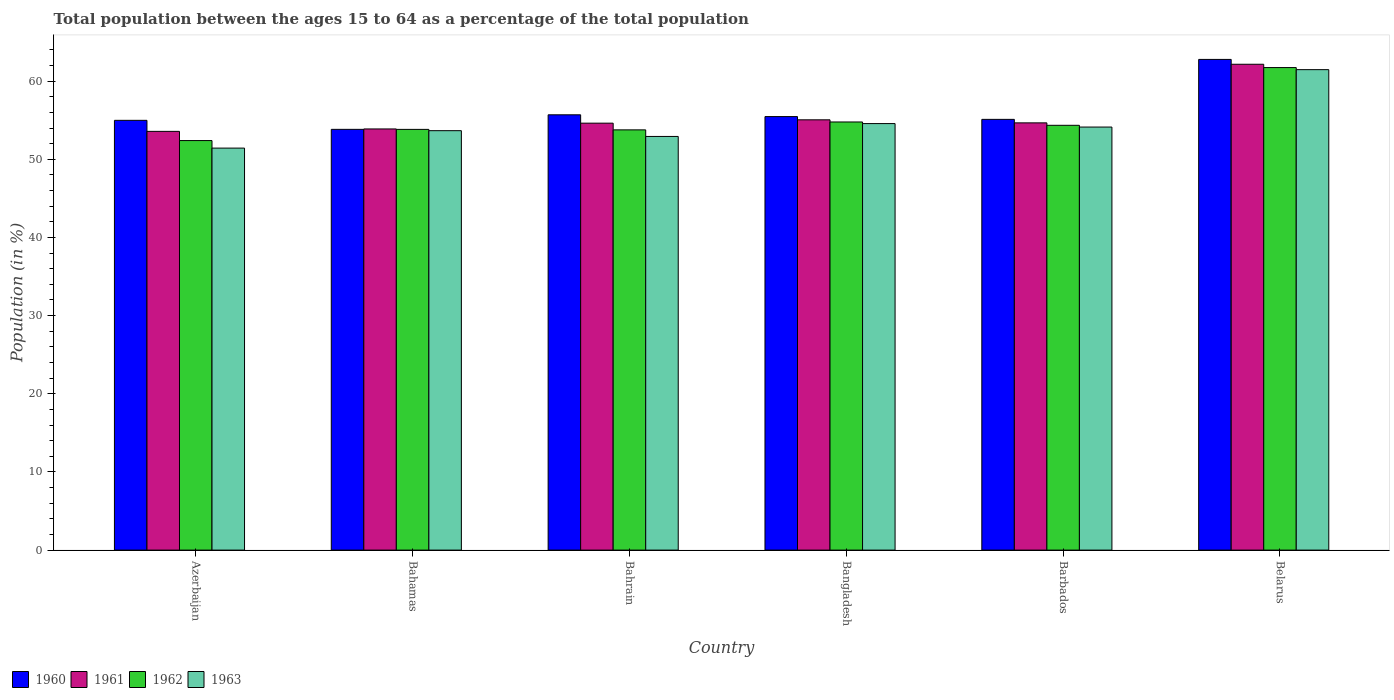How many groups of bars are there?
Ensure brevity in your answer.  6. Are the number of bars per tick equal to the number of legend labels?
Give a very brief answer. Yes. Are the number of bars on each tick of the X-axis equal?
Give a very brief answer. Yes. How many bars are there on the 1st tick from the left?
Give a very brief answer. 4. How many bars are there on the 4th tick from the right?
Keep it short and to the point. 4. What is the label of the 5th group of bars from the left?
Make the answer very short. Barbados. In how many cases, is the number of bars for a given country not equal to the number of legend labels?
Your response must be concise. 0. What is the percentage of the population ages 15 to 64 in 1960 in Barbados?
Give a very brief answer. 55.11. Across all countries, what is the maximum percentage of the population ages 15 to 64 in 1961?
Offer a very short reply. 62.16. Across all countries, what is the minimum percentage of the population ages 15 to 64 in 1961?
Make the answer very short. 53.57. In which country was the percentage of the population ages 15 to 64 in 1962 maximum?
Ensure brevity in your answer.  Belarus. In which country was the percentage of the population ages 15 to 64 in 1962 minimum?
Keep it short and to the point. Azerbaijan. What is the total percentage of the population ages 15 to 64 in 1963 in the graph?
Provide a short and direct response. 328.18. What is the difference between the percentage of the population ages 15 to 64 in 1961 in Azerbaijan and that in Bangladesh?
Ensure brevity in your answer.  -1.48. What is the difference between the percentage of the population ages 15 to 64 in 1960 in Bahrain and the percentage of the population ages 15 to 64 in 1962 in Bahamas?
Your response must be concise. 1.86. What is the average percentage of the population ages 15 to 64 in 1962 per country?
Provide a succinct answer. 55.14. What is the difference between the percentage of the population ages 15 to 64 of/in 1960 and percentage of the population ages 15 to 64 of/in 1963 in Bangladesh?
Offer a terse response. 0.89. In how many countries, is the percentage of the population ages 15 to 64 in 1962 greater than 46?
Your answer should be compact. 6. What is the ratio of the percentage of the population ages 15 to 64 in 1962 in Bahamas to that in Belarus?
Provide a succinct answer. 0.87. What is the difference between the highest and the second highest percentage of the population ages 15 to 64 in 1961?
Offer a very short reply. -7.5. What is the difference between the highest and the lowest percentage of the population ages 15 to 64 in 1961?
Offer a terse response. 8.59. Is it the case that in every country, the sum of the percentage of the population ages 15 to 64 in 1962 and percentage of the population ages 15 to 64 in 1963 is greater than the sum of percentage of the population ages 15 to 64 in 1960 and percentage of the population ages 15 to 64 in 1961?
Provide a short and direct response. No. What does the 1st bar from the right in Azerbaijan represents?
Offer a terse response. 1963. Is it the case that in every country, the sum of the percentage of the population ages 15 to 64 in 1962 and percentage of the population ages 15 to 64 in 1960 is greater than the percentage of the population ages 15 to 64 in 1963?
Your answer should be very brief. Yes. How many countries are there in the graph?
Ensure brevity in your answer.  6. What is the difference between two consecutive major ticks on the Y-axis?
Provide a short and direct response. 10. Where does the legend appear in the graph?
Provide a succinct answer. Bottom left. What is the title of the graph?
Your answer should be very brief. Total population between the ages 15 to 64 as a percentage of the total population. What is the label or title of the X-axis?
Your response must be concise. Country. What is the label or title of the Y-axis?
Give a very brief answer. Population (in %). What is the Population (in %) in 1960 in Azerbaijan?
Offer a very short reply. 54.98. What is the Population (in %) of 1961 in Azerbaijan?
Your response must be concise. 53.57. What is the Population (in %) of 1962 in Azerbaijan?
Provide a short and direct response. 52.4. What is the Population (in %) in 1963 in Azerbaijan?
Your answer should be very brief. 51.43. What is the Population (in %) of 1960 in Bahamas?
Keep it short and to the point. 53.83. What is the Population (in %) of 1961 in Bahamas?
Your answer should be very brief. 53.88. What is the Population (in %) in 1962 in Bahamas?
Keep it short and to the point. 53.83. What is the Population (in %) of 1963 in Bahamas?
Your response must be concise. 53.66. What is the Population (in %) of 1960 in Bahrain?
Keep it short and to the point. 55.69. What is the Population (in %) of 1961 in Bahrain?
Your response must be concise. 54.62. What is the Population (in %) of 1962 in Bahrain?
Ensure brevity in your answer.  53.77. What is the Population (in %) of 1963 in Bahrain?
Ensure brevity in your answer.  52.92. What is the Population (in %) of 1960 in Bangladesh?
Keep it short and to the point. 55.46. What is the Population (in %) in 1961 in Bangladesh?
Your answer should be very brief. 55.05. What is the Population (in %) of 1962 in Bangladesh?
Offer a terse response. 54.78. What is the Population (in %) in 1963 in Bangladesh?
Give a very brief answer. 54.57. What is the Population (in %) of 1960 in Barbados?
Your answer should be very brief. 55.11. What is the Population (in %) of 1961 in Barbados?
Ensure brevity in your answer.  54.66. What is the Population (in %) in 1962 in Barbados?
Your response must be concise. 54.35. What is the Population (in %) in 1963 in Barbados?
Provide a succinct answer. 54.12. What is the Population (in %) of 1960 in Belarus?
Offer a terse response. 62.78. What is the Population (in %) in 1961 in Belarus?
Your answer should be compact. 62.16. What is the Population (in %) of 1962 in Belarus?
Offer a terse response. 61.74. What is the Population (in %) in 1963 in Belarus?
Offer a terse response. 61.47. Across all countries, what is the maximum Population (in %) of 1960?
Offer a very short reply. 62.78. Across all countries, what is the maximum Population (in %) in 1961?
Give a very brief answer. 62.16. Across all countries, what is the maximum Population (in %) of 1962?
Make the answer very short. 61.74. Across all countries, what is the maximum Population (in %) of 1963?
Keep it short and to the point. 61.47. Across all countries, what is the minimum Population (in %) of 1960?
Make the answer very short. 53.83. Across all countries, what is the minimum Population (in %) in 1961?
Your answer should be compact. 53.57. Across all countries, what is the minimum Population (in %) in 1962?
Offer a very short reply. 52.4. Across all countries, what is the minimum Population (in %) of 1963?
Ensure brevity in your answer.  51.43. What is the total Population (in %) in 1960 in the graph?
Give a very brief answer. 337.86. What is the total Population (in %) of 1961 in the graph?
Give a very brief answer. 333.95. What is the total Population (in %) in 1962 in the graph?
Make the answer very short. 330.85. What is the total Population (in %) of 1963 in the graph?
Your response must be concise. 328.18. What is the difference between the Population (in %) of 1960 in Azerbaijan and that in Bahamas?
Provide a short and direct response. 1.15. What is the difference between the Population (in %) in 1961 in Azerbaijan and that in Bahamas?
Ensure brevity in your answer.  -0.31. What is the difference between the Population (in %) in 1962 in Azerbaijan and that in Bahamas?
Provide a succinct answer. -1.43. What is the difference between the Population (in %) of 1963 in Azerbaijan and that in Bahamas?
Your answer should be compact. -2.23. What is the difference between the Population (in %) of 1960 in Azerbaijan and that in Bahrain?
Provide a succinct answer. -0.71. What is the difference between the Population (in %) of 1961 in Azerbaijan and that in Bahrain?
Your answer should be very brief. -1.05. What is the difference between the Population (in %) in 1962 in Azerbaijan and that in Bahrain?
Your answer should be very brief. -1.37. What is the difference between the Population (in %) of 1963 in Azerbaijan and that in Bahrain?
Give a very brief answer. -1.49. What is the difference between the Population (in %) in 1960 in Azerbaijan and that in Bangladesh?
Your answer should be very brief. -0.48. What is the difference between the Population (in %) of 1961 in Azerbaijan and that in Bangladesh?
Your answer should be compact. -1.48. What is the difference between the Population (in %) in 1962 in Azerbaijan and that in Bangladesh?
Make the answer very short. -2.38. What is the difference between the Population (in %) of 1963 in Azerbaijan and that in Bangladesh?
Provide a succinct answer. -3.14. What is the difference between the Population (in %) in 1960 in Azerbaijan and that in Barbados?
Provide a succinct answer. -0.12. What is the difference between the Population (in %) in 1961 in Azerbaijan and that in Barbados?
Make the answer very short. -1.09. What is the difference between the Population (in %) of 1962 in Azerbaijan and that in Barbados?
Keep it short and to the point. -1.95. What is the difference between the Population (in %) in 1963 in Azerbaijan and that in Barbados?
Keep it short and to the point. -2.69. What is the difference between the Population (in %) of 1960 in Azerbaijan and that in Belarus?
Provide a succinct answer. -7.79. What is the difference between the Population (in %) in 1961 in Azerbaijan and that in Belarus?
Make the answer very short. -8.59. What is the difference between the Population (in %) in 1962 in Azerbaijan and that in Belarus?
Provide a succinct answer. -9.34. What is the difference between the Population (in %) of 1963 in Azerbaijan and that in Belarus?
Offer a very short reply. -10.04. What is the difference between the Population (in %) in 1960 in Bahamas and that in Bahrain?
Your response must be concise. -1.86. What is the difference between the Population (in %) in 1961 in Bahamas and that in Bahrain?
Make the answer very short. -0.74. What is the difference between the Population (in %) of 1962 in Bahamas and that in Bahrain?
Offer a terse response. 0.06. What is the difference between the Population (in %) in 1963 in Bahamas and that in Bahrain?
Make the answer very short. 0.74. What is the difference between the Population (in %) in 1960 in Bahamas and that in Bangladesh?
Make the answer very short. -1.63. What is the difference between the Population (in %) of 1961 in Bahamas and that in Bangladesh?
Provide a succinct answer. -1.17. What is the difference between the Population (in %) in 1962 in Bahamas and that in Bangladesh?
Provide a succinct answer. -0.95. What is the difference between the Population (in %) of 1963 in Bahamas and that in Bangladesh?
Your response must be concise. -0.91. What is the difference between the Population (in %) of 1960 in Bahamas and that in Barbados?
Ensure brevity in your answer.  -1.28. What is the difference between the Population (in %) in 1961 in Bahamas and that in Barbados?
Offer a very short reply. -0.78. What is the difference between the Population (in %) in 1962 in Bahamas and that in Barbados?
Offer a very short reply. -0.52. What is the difference between the Population (in %) of 1963 in Bahamas and that in Barbados?
Make the answer very short. -0.46. What is the difference between the Population (in %) of 1960 in Bahamas and that in Belarus?
Your answer should be very brief. -8.95. What is the difference between the Population (in %) of 1961 in Bahamas and that in Belarus?
Provide a succinct answer. -8.28. What is the difference between the Population (in %) of 1962 in Bahamas and that in Belarus?
Ensure brevity in your answer.  -7.91. What is the difference between the Population (in %) of 1963 in Bahamas and that in Belarus?
Your response must be concise. -7.81. What is the difference between the Population (in %) of 1960 in Bahrain and that in Bangladesh?
Give a very brief answer. 0.23. What is the difference between the Population (in %) in 1961 in Bahrain and that in Bangladesh?
Your answer should be very brief. -0.43. What is the difference between the Population (in %) in 1962 in Bahrain and that in Bangladesh?
Keep it short and to the point. -1.01. What is the difference between the Population (in %) of 1963 in Bahrain and that in Bangladesh?
Keep it short and to the point. -1.65. What is the difference between the Population (in %) in 1960 in Bahrain and that in Barbados?
Your answer should be very brief. 0.58. What is the difference between the Population (in %) of 1961 in Bahrain and that in Barbados?
Offer a very short reply. -0.04. What is the difference between the Population (in %) of 1962 in Bahrain and that in Barbados?
Offer a terse response. -0.58. What is the difference between the Population (in %) of 1963 in Bahrain and that in Barbados?
Provide a succinct answer. -1.2. What is the difference between the Population (in %) in 1960 in Bahrain and that in Belarus?
Keep it short and to the point. -7.09. What is the difference between the Population (in %) of 1961 in Bahrain and that in Belarus?
Your answer should be very brief. -7.54. What is the difference between the Population (in %) of 1962 in Bahrain and that in Belarus?
Give a very brief answer. -7.97. What is the difference between the Population (in %) of 1963 in Bahrain and that in Belarus?
Offer a terse response. -8.55. What is the difference between the Population (in %) in 1960 in Bangladesh and that in Barbados?
Provide a short and direct response. 0.36. What is the difference between the Population (in %) in 1961 in Bangladesh and that in Barbados?
Provide a short and direct response. 0.39. What is the difference between the Population (in %) of 1962 in Bangladesh and that in Barbados?
Ensure brevity in your answer.  0.43. What is the difference between the Population (in %) of 1963 in Bangladesh and that in Barbados?
Offer a terse response. 0.45. What is the difference between the Population (in %) of 1960 in Bangladesh and that in Belarus?
Ensure brevity in your answer.  -7.32. What is the difference between the Population (in %) in 1961 in Bangladesh and that in Belarus?
Provide a succinct answer. -7.11. What is the difference between the Population (in %) of 1962 in Bangladesh and that in Belarus?
Your answer should be compact. -6.96. What is the difference between the Population (in %) of 1963 in Bangladesh and that in Belarus?
Give a very brief answer. -6.9. What is the difference between the Population (in %) of 1960 in Barbados and that in Belarus?
Offer a very short reply. -7.67. What is the difference between the Population (in %) in 1961 in Barbados and that in Belarus?
Your response must be concise. -7.5. What is the difference between the Population (in %) of 1962 in Barbados and that in Belarus?
Provide a short and direct response. -7.39. What is the difference between the Population (in %) of 1963 in Barbados and that in Belarus?
Provide a succinct answer. -7.34. What is the difference between the Population (in %) in 1960 in Azerbaijan and the Population (in %) in 1961 in Bahamas?
Give a very brief answer. 1.1. What is the difference between the Population (in %) of 1960 in Azerbaijan and the Population (in %) of 1962 in Bahamas?
Give a very brief answer. 1.16. What is the difference between the Population (in %) in 1960 in Azerbaijan and the Population (in %) in 1963 in Bahamas?
Your answer should be very brief. 1.32. What is the difference between the Population (in %) in 1961 in Azerbaijan and the Population (in %) in 1962 in Bahamas?
Provide a short and direct response. -0.25. What is the difference between the Population (in %) in 1961 in Azerbaijan and the Population (in %) in 1963 in Bahamas?
Keep it short and to the point. -0.09. What is the difference between the Population (in %) of 1962 in Azerbaijan and the Population (in %) of 1963 in Bahamas?
Ensure brevity in your answer.  -1.27. What is the difference between the Population (in %) of 1960 in Azerbaijan and the Population (in %) of 1961 in Bahrain?
Give a very brief answer. 0.36. What is the difference between the Population (in %) in 1960 in Azerbaijan and the Population (in %) in 1962 in Bahrain?
Give a very brief answer. 1.22. What is the difference between the Population (in %) in 1960 in Azerbaijan and the Population (in %) in 1963 in Bahrain?
Your answer should be very brief. 2.06. What is the difference between the Population (in %) in 1961 in Azerbaijan and the Population (in %) in 1962 in Bahrain?
Make the answer very short. -0.19. What is the difference between the Population (in %) in 1961 in Azerbaijan and the Population (in %) in 1963 in Bahrain?
Offer a very short reply. 0.65. What is the difference between the Population (in %) in 1962 in Azerbaijan and the Population (in %) in 1963 in Bahrain?
Your answer should be very brief. -0.53. What is the difference between the Population (in %) of 1960 in Azerbaijan and the Population (in %) of 1961 in Bangladesh?
Offer a terse response. -0.07. What is the difference between the Population (in %) of 1960 in Azerbaijan and the Population (in %) of 1962 in Bangladesh?
Keep it short and to the point. 0.21. What is the difference between the Population (in %) of 1960 in Azerbaijan and the Population (in %) of 1963 in Bangladesh?
Keep it short and to the point. 0.41. What is the difference between the Population (in %) in 1961 in Azerbaijan and the Population (in %) in 1962 in Bangladesh?
Make the answer very short. -1.2. What is the difference between the Population (in %) of 1961 in Azerbaijan and the Population (in %) of 1963 in Bangladesh?
Keep it short and to the point. -1. What is the difference between the Population (in %) in 1962 in Azerbaijan and the Population (in %) in 1963 in Bangladesh?
Your response must be concise. -2.17. What is the difference between the Population (in %) of 1960 in Azerbaijan and the Population (in %) of 1961 in Barbados?
Your response must be concise. 0.32. What is the difference between the Population (in %) of 1960 in Azerbaijan and the Population (in %) of 1962 in Barbados?
Provide a short and direct response. 0.64. What is the difference between the Population (in %) in 1960 in Azerbaijan and the Population (in %) in 1963 in Barbados?
Give a very brief answer. 0.86. What is the difference between the Population (in %) in 1961 in Azerbaijan and the Population (in %) in 1962 in Barbados?
Provide a succinct answer. -0.78. What is the difference between the Population (in %) of 1961 in Azerbaijan and the Population (in %) of 1963 in Barbados?
Offer a very short reply. -0.55. What is the difference between the Population (in %) in 1962 in Azerbaijan and the Population (in %) in 1963 in Barbados?
Offer a terse response. -1.73. What is the difference between the Population (in %) of 1960 in Azerbaijan and the Population (in %) of 1961 in Belarus?
Offer a terse response. -7.17. What is the difference between the Population (in %) of 1960 in Azerbaijan and the Population (in %) of 1962 in Belarus?
Provide a short and direct response. -6.75. What is the difference between the Population (in %) in 1960 in Azerbaijan and the Population (in %) in 1963 in Belarus?
Offer a terse response. -6.48. What is the difference between the Population (in %) of 1961 in Azerbaijan and the Population (in %) of 1962 in Belarus?
Ensure brevity in your answer.  -8.16. What is the difference between the Population (in %) of 1961 in Azerbaijan and the Population (in %) of 1963 in Belarus?
Give a very brief answer. -7.9. What is the difference between the Population (in %) in 1962 in Azerbaijan and the Population (in %) in 1963 in Belarus?
Give a very brief answer. -9.07. What is the difference between the Population (in %) in 1960 in Bahamas and the Population (in %) in 1961 in Bahrain?
Your answer should be very brief. -0.79. What is the difference between the Population (in %) in 1960 in Bahamas and the Population (in %) in 1962 in Bahrain?
Offer a very short reply. 0.07. What is the difference between the Population (in %) of 1960 in Bahamas and the Population (in %) of 1963 in Bahrain?
Your answer should be very brief. 0.91. What is the difference between the Population (in %) in 1961 in Bahamas and the Population (in %) in 1962 in Bahrain?
Your answer should be compact. 0.12. What is the difference between the Population (in %) in 1961 in Bahamas and the Population (in %) in 1963 in Bahrain?
Your answer should be very brief. 0.96. What is the difference between the Population (in %) in 1962 in Bahamas and the Population (in %) in 1963 in Bahrain?
Your response must be concise. 0.9. What is the difference between the Population (in %) in 1960 in Bahamas and the Population (in %) in 1961 in Bangladesh?
Your answer should be compact. -1.22. What is the difference between the Population (in %) in 1960 in Bahamas and the Population (in %) in 1962 in Bangladesh?
Offer a very short reply. -0.94. What is the difference between the Population (in %) of 1960 in Bahamas and the Population (in %) of 1963 in Bangladesh?
Your response must be concise. -0.74. What is the difference between the Population (in %) in 1961 in Bahamas and the Population (in %) in 1962 in Bangladesh?
Provide a short and direct response. -0.89. What is the difference between the Population (in %) in 1961 in Bahamas and the Population (in %) in 1963 in Bangladesh?
Offer a terse response. -0.69. What is the difference between the Population (in %) of 1962 in Bahamas and the Population (in %) of 1963 in Bangladesh?
Your answer should be compact. -0.74. What is the difference between the Population (in %) of 1960 in Bahamas and the Population (in %) of 1961 in Barbados?
Provide a short and direct response. -0.83. What is the difference between the Population (in %) of 1960 in Bahamas and the Population (in %) of 1962 in Barbados?
Offer a terse response. -0.52. What is the difference between the Population (in %) in 1960 in Bahamas and the Population (in %) in 1963 in Barbados?
Ensure brevity in your answer.  -0.29. What is the difference between the Population (in %) of 1961 in Bahamas and the Population (in %) of 1962 in Barbados?
Your answer should be compact. -0.46. What is the difference between the Population (in %) of 1961 in Bahamas and the Population (in %) of 1963 in Barbados?
Give a very brief answer. -0.24. What is the difference between the Population (in %) of 1962 in Bahamas and the Population (in %) of 1963 in Barbados?
Offer a very short reply. -0.3. What is the difference between the Population (in %) in 1960 in Bahamas and the Population (in %) in 1961 in Belarus?
Make the answer very short. -8.33. What is the difference between the Population (in %) in 1960 in Bahamas and the Population (in %) in 1962 in Belarus?
Your response must be concise. -7.91. What is the difference between the Population (in %) in 1960 in Bahamas and the Population (in %) in 1963 in Belarus?
Your answer should be compact. -7.64. What is the difference between the Population (in %) in 1961 in Bahamas and the Population (in %) in 1962 in Belarus?
Provide a short and direct response. -7.85. What is the difference between the Population (in %) in 1961 in Bahamas and the Population (in %) in 1963 in Belarus?
Make the answer very short. -7.59. What is the difference between the Population (in %) of 1962 in Bahamas and the Population (in %) of 1963 in Belarus?
Your response must be concise. -7.64. What is the difference between the Population (in %) in 1960 in Bahrain and the Population (in %) in 1961 in Bangladesh?
Provide a succinct answer. 0.64. What is the difference between the Population (in %) in 1960 in Bahrain and the Population (in %) in 1962 in Bangladesh?
Provide a succinct answer. 0.92. What is the difference between the Population (in %) of 1960 in Bahrain and the Population (in %) of 1963 in Bangladesh?
Ensure brevity in your answer.  1.12. What is the difference between the Population (in %) of 1961 in Bahrain and the Population (in %) of 1962 in Bangladesh?
Make the answer very short. -0.15. What is the difference between the Population (in %) of 1961 in Bahrain and the Population (in %) of 1963 in Bangladesh?
Your response must be concise. 0.05. What is the difference between the Population (in %) of 1962 in Bahrain and the Population (in %) of 1963 in Bangladesh?
Provide a succinct answer. -0.8. What is the difference between the Population (in %) in 1960 in Bahrain and the Population (in %) in 1961 in Barbados?
Make the answer very short. 1.03. What is the difference between the Population (in %) in 1960 in Bahrain and the Population (in %) in 1962 in Barbados?
Your answer should be very brief. 1.34. What is the difference between the Population (in %) of 1960 in Bahrain and the Population (in %) of 1963 in Barbados?
Keep it short and to the point. 1.57. What is the difference between the Population (in %) in 1961 in Bahrain and the Population (in %) in 1962 in Barbados?
Give a very brief answer. 0.27. What is the difference between the Population (in %) of 1961 in Bahrain and the Population (in %) of 1963 in Barbados?
Offer a terse response. 0.5. What is the difference between the Population (in %) of 1962 in Bahrain and the Population (in %) of 1963 in Barbados?
Give a very brief answer. -0.36. What is the difference between the Population (in %) in 1960 in Bahrain and the Population (in %) in 1961 in Belarus?
Provide a short and direct response. -6.47. What is the difference between the Population (in %) of 1960 in Bahrain and the Population (in %) of 1962 in Belarus?
Make the answer very short. -6.04. What is the difference between the Population (in %) of 1960 in Bahrain and the Population (in %) of 1963 in Belarus?
Keep it short and to the point. -5.78. What is the difference between the Population (in %) of 1961 in Bahrain and the Population (in %) of 1962 in Belarus?
Provide a succinct answer. -7.11. What is the difference between the Population (in %) in 1961 in Bahrain and the Population (in %) in 1963 in Belarus?
Ensure brevity in your answer.  -6.85. What is the difference between the Population (in %) in 1962 in Bahrain and the Population (in %) in 1963 in Belarus?
Keep it short and to the point. -7.7. What is the difference between the Population (in %) of 1960 in Bangladesh and the Population (in %) of 1961 in Barbados?
Provide a succinct answer. 0.8. What is the difference between the Population (in %) in 1960 in Bangladesh and the Population (in %) in 1962 in Barbados?
Ensure brevity in your answer.  1.12. What is the difference between the Population (in %) of 1960 in Bangladesh and the Population (in %) of 1963 in Barbados?
Offer a terse response. 1.34. What is the difference between the Population (in %) in 1961 in Bangladesh and the Population (in %) in 1962 in Barbados?
Provide a succinct answer. 0.7. What is the difference between the Population (in %) of 1961 in Bangladesh and the Population (in %) of 1963 in Barbados?
Provide a succinct answer. 0.93. What is the difference between the Population (in %) in 1962 in Bangladesh and the Population (in %) in 1963 in Barbados?
Offer a very short reply. 0.65. What is the difference between the Population (in %) in 1960 in Bangladesh and the Population (in %) in 1961 in Belarus?
Offer a very short reply. -6.69. What is the difference between the Population (in %) in 1960 in Bangladesh and the Population (in %) in 1962 in Belarus?
Make the answer very short. -6.27. What is the difference between the Population (in %) of 1960 in Bangladesh and the Population (in %) of 1963 in Belarus?
Provide a succinct answer. -6. What is the difference between the Population (in %) of 1961 in Bangladesh and the Population (in %) of 1962 in Belarus?
Provide a short and direct response. -6.69. What is the difference between the Population (in %) of 1961 in Bangladesh and the Population (in %) of 1963 in Belarus?
Provide a short and direct response. -6.42. What is the difference between the Population (in %) of 1962 in Bangladesh and the Population (in %) of 1963 in Belarus?
Make the answer very short. -6.69. What is the difference between the Population (in %) in 1960 in Barbados and the Population (in %) in 1961 in Belarus?
Your answer should be compact. -7.05. What is the difference between the Population (in %) of 1960 in Barbados and the Population (in %) of 1962 in Belarus?
Your response must be concise. -6.63. What is the difference between the Population (in %) of 1960 in Barbados and the Population (in %) of 1963 in Belarus?
Provide a short and direct response. -6.36. What is the difference between the Population (in %) of 1961 in Barbados and the Population (in %) of 1962 in Belarus?
Provide a succinct answer. -7.07. What is the difference between the Population (in %) in 1961 in Barbados and the Population (in %) in 1963 in Belarus?
Give a very brief answer. -6.81. What is the difference between the Population (in %) of 1962 in Barbados and the Population (in %) of 1963 in Belarus?
Provide a succinct answer. -7.12. What is the average Population (in %) in 1960 per country?
Your answer should be compact. 56.31. What is the average Population (in %) in 1961 per country?
Your answer should be very brief. 55.66. What is the average Population (in %) in 1962 per country?
Give a very brief answer. 55.14. What is the average Population (in %) in 1963 per country?
Offer a terse response. 54.7. What is the difference between the Population (in %) in 1960 and Population (in %) in 1961 in Azerbaijan?
Your answer should be compact. 1.41. What is the difference between the Population (in %) in 1960 and Population (in %) in 1962 in Azerbaijan?
Give a very brief answer. 2.59. What is the difference between the Population (in %) in 1960 and Population (in %) in 1963 in Azerbaijan?
Provide a short and direct response. 3.55. What is the difference between the Population (in %) of 1961 and Population (in %) of 1962 in Azerbaijan?
Your answer should be very brief. 1.18. What is the difference between the Population (in %) in 1961 and Population (in %) in 1963 in Azerbaijan?
Provide a short and direct response. 2.14. What is the difference between the Population (in %) in 1962 and Population (in %) in 1963 in Azerbaijan?
Provide a succinct answer. 0.96. What is the difference between the Population (in %) in 1960 and Population (in %) in 1961 in Bahamas?
Make the answer very short. -0.05. What is the difference between the Population (in %) of 1960 and Population (in %) of 1962 in Bahamas?
Offer a terse response. 0. What is the difference between the Population (in %) of 1960 and Population (in %) of 1963 in Bahamas?
Provide a succinct answer. 0.17. What is the difference between the Population (in %) of 1961 and Population (in %) of 1962 in Bahamas?
Give a very brief answer. 0.06. What is the difference between the Population (in %) in 1961 and Population (in %) in 1963 in Bahamas?
Offer a very short reply. 0.22. What is the difference between the Population (in %) of 1962 and Population (in %) of 1963 in Bahamas?
Make the answer very short. 0.17. What is the difference between the Population (in %) in 1960 and Population (in %) in 1961 in Bahrain?
Make the answer very short. 1.07. What is the difference between the Population (in %) in 1960 and Population (in %) in 1962 in Bahrain?
Provide a short and direct response. 1.93. What is the difference between the Population (in %) of 1960 and Population (in %) of 1963 in Bahrain?
Keep it short and to the point. 2.77. What is the difference between the Population (in %) of 1961 and Population (in %) of 1962 in Bahrain?
Provide a short and direct response. 0.86. What is the difference between the Population (in %) of 1961 and Population (in %) of 1963 in Bahrain?
Offer a very short reply. 1.7. What is the difference between the Population (in %) of 1962 and Population (in %) of 1963 in Bahrain?
Offer a very short reply. 0.84. What is the difference between the Population (in %) of 1960 and Population (in %) of 1961 in Bangladesh?
Make the answer very short. 0.41. What is the difference between the Population (in %) of 1960 and Population (in %) of 1962 in Bangladesh?
Provide a short and direct response. 0.69. What is the difference between the Population (in %) of 1960 and Population (in %) of 1963 in Bangladesh?
Keep it short and to the point. 0.89. What is the difference between the Population (in %) of 1961 and Population (in %) of 1962 in Bangladesh?
Offer a very short reply. 0.28. What is the difference between the Population (in %) of 1961 and Population (in %) of 1963 in Bangladesh?
Provide a succinct answer. 0.48. What is the difference between the Population (in %) in 1962 and Population (in %) in 1963 in Bangladesh?
Provide a short and direct response. 0.21. What is the difference between the Population (in %) in 1960 and Population (in %) in 1961 in Barbados?
Provide a succinct answer. 0.45. What is the difference between the Population (in %) of 1960 and Population (in %) of 1962 in Barbados?
Offer a terse response. 0.76. What is the difference between the Population (in %) of 1960 and Population (in %) of 1963 in Barbados?
Your answer should be compact. 0.98. What is the difference between the Population (in %) of 1961 and Population (in %) of 1962 in Barbados?
Offer a terse response. 0.31. What is the difference between the Population (in %) in 1961 and Population (in %) in 1963 in Barbados?
Provide a succinct answer. 0.54. What is the difference between the Population (in %) of 1962 and Population (in %) of 1963 in Barbados?
Your answer should be compact. 0.22. What is the difference between the Population (in %) in 1960 and Population (in %) in 1961 in Belarus?
Give a very brief answer. 0.62. What is the difference between the Population (in %) in 1960 and Population (in %) in 1962 in Belarus?
Your answer should be compact. 1.04. What is the difference between the Population (in %) in 1960 and Population (in %) in 1963 in Belarus?
Offer a very short reply. 1.31. What is the difference between the Population (in %) in 1961 and Population (in %) in 1962 in Belarus?
Give a very brief answer. 0.42. What is the difference between the Population (in %) in 1961 and Population (in %) in 1963 in Belarus?
Keep it short and to the point. 0.69. What is the difference between the Population (in %) of 1962 and Population (in %) of 1963 in Belarus?
Your answer should be very brief. 0.27. What is the ratio of the Population (in %) in 1960 in Azerbaijan to that in Bahamas?
Your answer should be very brief. 1.02. What is the ratio of the Population (in %) of 1961 in Azerbaijan to that in Bahamas?
Provide a short and direct response. 0.99. What is the ratio of the Population (in %) of 1962 in Azerbaijan to that in Bahamas?
Offer a very short reply. 0.97. What is the ratio of the Population (in %) of 1963 in Azerbaijan to that in Bahamas?
Give a very brief answer. 0.96. What is the ratio of the Population (in %) in 1960 in Azerbaijan to that in Bahrain?
Offer a terse response. 0.99. What is the ratio of the Population (in %) in 1961 in Azerbaijan to that in Bahrain?
Offer a terse response. 0.98. What is the ratio of the Population (in %) in 1962 in Azerbaijan to that in Bahrain?
Your answer should be compact. 0.97. What is the ratio of the Population (in %) in 1963 in Azerbaijan to that in Bahrain?
Offer a terse response. 0.97. What is the ratio of the Population (in %) of 1960 in Azerbaijan to that in Bangladesh?
Give a very brief answer. 0.99. What is the ratio of the Population (in %) of 1961 in Azerbaijan to that in Bangladesh?
Offer a terse response. 0.97. What is the ratio of the Population (in %) in 1962 in Azerbaijan to that in Bangladesh?
Your response must be concise. 0.96. What is the ratio of the Population (in %) of 1963 in Azerbaijan to that in Bangladesh?
Ensure brevity in your answer.  0.94. What is the ratio of the Population (in %) of 1961 in Azerbaijan to that in Barbados?
Your response must be concise. 0.98. What is the ratio of the Population (in %) in 1962 in Azerbaijan to that in Barbados?
Provide a short and direct response. 0.96. What is the ratio of the Population (in %) of 1963 in Azerbaijan to that in Barbados?
Your response must be concise. 0.95. What is the ratio of the Population (in %) in 1960 in Azerbaijan to that in Belarus?
Provide a short and direct response. 0.88. What is the ratio of the Population (in %) in 1961 in Azerbaijan to that in Belarus?
Your answer should be compact. 0.86. What is the ratio of the Population (in %) of 1962 in Azerbaijan to that in Belarus?
Your response must be concise. 0.85. What is the ratio of the Population (in %) in 1963 in Azerbaijan to that in Belarus?
Provide a short and direct response. 0.84. What is the ratio of the Population (in %) in 1960 in Bahamas to that in Bahrain?
Offer a very short reply. 0.97. What is the ratio of the Population (in %) of 1961 in Bahamas to that in Bahrain?
Offer a very short reply. 0.99. What is the ratio of the Population (in %) in 1962 in Bahamas to that in Bahrain?
Your answer should be compact. 1. What is the ratio of the Population (in %) in 1960 in Bahamas to that in Bangladesh?
Give a very brief answer. 0.97. What is the ratio of the Population (in %) of 1961 in Bahamas to that in Bangladesh?
Provide a short and direct response. 0.98. What is the ratio of the Population (in %) in 1962 in Bahamas to that in Bangladesh?
Keep it short and to the point. 0.98. What is the ratio of the Population (in %) in 1963 in Bahamas to that in Bangladesh?
Provide a succinct answer. 0.98. What is the ratio of the Population (in %) of 1960 in Bahamas to that in Barbados?
Provide a succinct answer. 0.98. What is the ratio of the Population (in %) of 1961 in Bahamas to that in Barbados?
Ensure brevity in your answer.  0.99. What is the ratio of the Population (in %) in 1960 in Bahamas to that in Belarus?
Keep it short and to the point. 0.86. What is the ratio of the Population (in %) of 1961 in Bahamas to that in Belarus?
Offer a very short reply. 0.87. What is the ratio of the Population (in %) of 1962 in Bahamas to that in Belarus?
Your answer should be compact. 0.87. What is the ratio of the Population (in %) in 1963 in Bahamas to that in Belarus?
Your response must be concise. 0.87. What is the ratio of the Population (in %) in 1961 in Bahrain to that in Bangladesh?
Offer a very short reply. 0.99. What is the ratio of the Population (in %) of 1962 in Bahrain to that in Bangladesh?
Your response must be concise. 0.98. What is the ratio of the Population (in %) in 1963 in Bahrain to that in Bangladesh?
Provide a succinct answer. 0.97. What is the ratio of the Population (in %) in 1960 in Bahrain to that in Barbados?
Ensure brevity in your answer.  1.01. What is the ratio of the Population (in %) of 1962 in Bahrain to that in Barbados?
Keep it short and to the point. 0.99. What is the ratio of the Population (in %) in 1963 in Bahrain to that in Barbados?
Your answer should be very brief. 0.98. What is the ratio of the Population (in %) in 1960 in Bahrain to that in Belarus?
Your answer should be very brief. 0.89. What is the ratio of the Population (in %) of 1961 in Bahrain to that in Belarus?
Keep it short and to the point. 0.88. What is the ratio of the Population (in %) of 1962 in Bahrain to that in Belarus?
Ensure brevity in your answer.  0.87. What is the ratio of the Population (in %) of 1963 in Bahrain to that in Belarus?
Make the answer very short. 0.86. What is the ratio of the Population (in %) of 1960 in Bangladesh to that in Barbados?
Your answer should be very brief. 1.01. What is the ratio of the Population (in %) of 1961 in Bangladesh to that in Barbados?
Offer a very short reply. 1.01. What is the ratio of the Population (in %) of 1962 in Bangladesh to that in Barbados?
Your answer should be very brief. 1.01. What is the ratio of the Population (in %) of 1963 in Bangladesh to that in Barbados?
Provide a succinct answer. 1.01. What is the ratio of the Population (in %) in 1960 in Bangladesh to that in Belarus?
Your response must be concise. 0.88. What is the ratio of the Population (in %) of 1961 in Bangladesh to that in Belarus?
Ensure brevity in your answer.  0.89. What is the ratio of the Population (in %) of 1962 in Bangladesh to that in Belarus?
Provide a succinct answer. 0.89. What is the ratio of the Population (in %) of 1963 in Bangladesh to that in Belarus?
Offer a terse response. 0.89. What is the ratio of the Population (in %) of 1960 in Barbados to that in Belarus?
Your answer should be compact. 0.88. What is the ratio of the Population (in %) of 1961 in Barbados to that in Belarus?
Your answer should be compact. 0.88. What is the ratio of the Population (in %) in 1962 in Barbados to that in Belarus?
Your answer should be compact. 0.88. What is the ratio of the Population (in %) of 1963 in Barbados to that in Belarus?
Provide a succinct answer. 0.88. What is the difference between the highest and the second highest Population (in %) in 1960?
Ensure brevity in your answer.  7.09. What is the difference between the highest and the second highest Population (in %) in 1961?
Give a very brief answer. 7.11. What is the difference between the highest and the second highest Population (in %) of 1962?
Make the answer very short. 6.96. What is the difference between the highest and the second highest Population (in %) in 1963?
Your answer should be compact. 6.9. What is the difference between the highest and the lowest Population (in %) in 1960?
Offer a terse response. 8.95. What is the difference between the highest and the lowest Population (in %) of 1961?
Provide a succinct answer. 8.59. What is the difference between the highest and the lowest Population (in %) of 1962?
Offer a terse response. 9.34. What is the difference between the highest and the lowest Population (in %) of 1963?
Give a very brief answer. 10.04. 